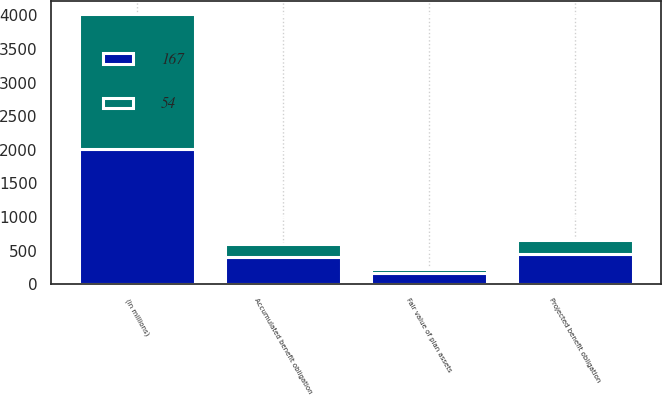Convert chart. <chart><loc_0><loc_0><loc_500><loc_500><stacked_bar_chart><ecel><fcel>(in millions)<fcel>Projected benefit obligation<fcel>Accumulated benefit obligation<fcel>Fair value of plan assets<nl><fcel>167<fcel>2011<fcel>448<fcel>412<fcel>167<nl><fcel>54<fcel>2010<fcel>209<fcel>192<fcel>54<nl></chart> 